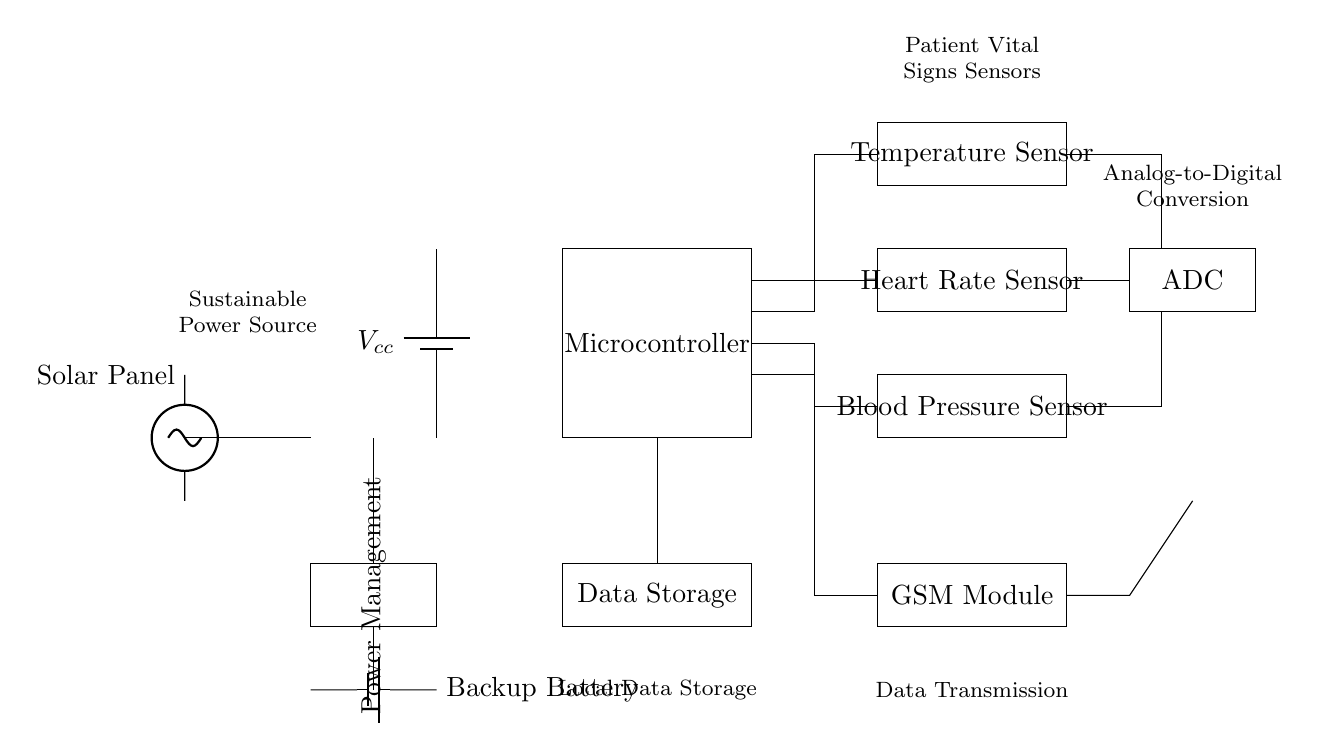What is the main power source for this circuit? The main power source is a solar panel, as it is represented in the circuit and supplies energy to the entire system. Additionally, there is a backup battery to maintain functionality when solar energy is not available.
Answer: Solar panel How many sensors are connected to the microcontroller? There are three sensors connected to the microcontroller: a temperature sensor, a heart rate sensor, and a blood pressure sensor. These sensors are visible in the upper section of the diagram, each clearly labeled.
Answer: Three What component is used for data storage? The component used for data storage is labeled as "Data Storage" in the circuit diagram. It is connected to the microcontroller and appears below it in the layout, indicating its function in storing patient data.
Answer: Data Storage What is the purpose of the antenna in this circuit? The purpose of the antenna is for data transmission, specifically to facilitate communication between the GSM module and external networks. The antenna is indicated in the circuit layout as being connected to the GSM module, crucial for sending vital signs data remotely.
Answer: Data transmission What component converts analog signals to digital signals? The component that converts analog signals to digital signals is labeled as "ADC," which stands for Analog-to-Digital Converter. This component is positioned to the right of the sensors, signifying its role in processing the sensor outputs for further handling by the microcontroller.
Answer: ADC How does the circuit ensure a continuous power supply? The circuit ensures a continuous power supply through a combination of a solar panel and a backup battery. The solar panel primarily powers the system, while the backup battery is used when there's insufficient solar energy. This design is essential for remote healthcare settings where reliability is crucial.
Answer: Solar panel and backup battery 